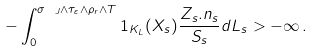Convert formula to latex. <formula><loc_0><loc_0><loc_500><loc_500>- \int _ { 0 } ^ { \sigma _ { \ J } \wedge \tau _ { \varepsilon } \wedge \rho _ { r } \wedge T } { 1 } _ { K _ { L } } ( X _ { s } ) \frac { Z _ { s } . n _ { s } } { S _ { s } } d L _ { s } > - \infty \, .</formula> 